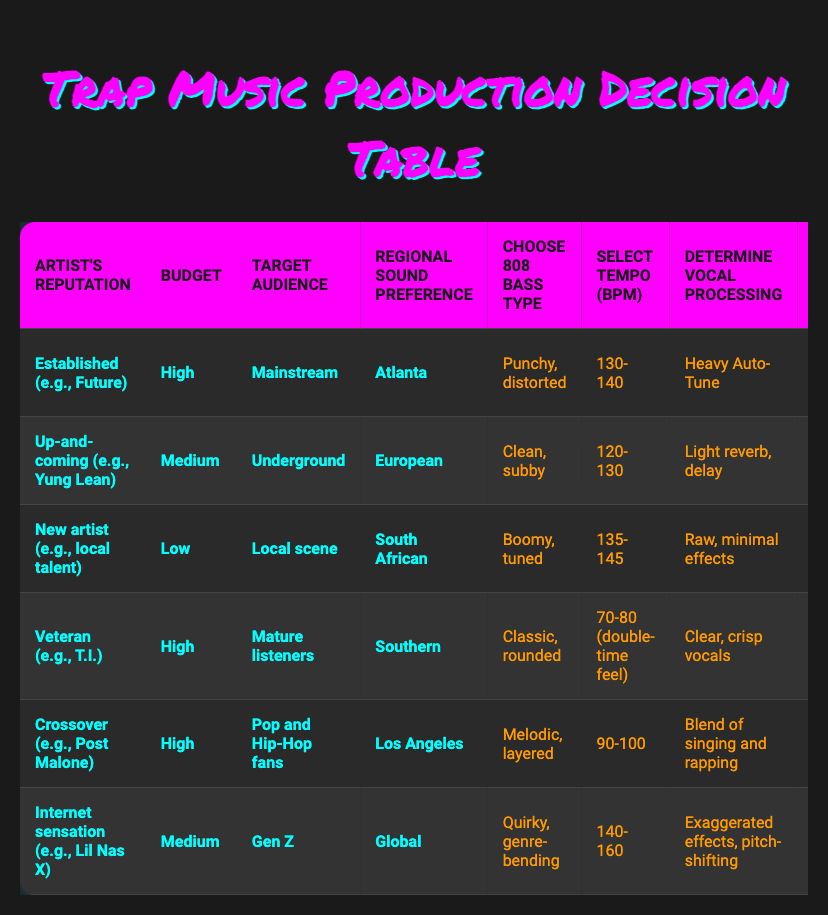What 808 bass type is used by established artists like Future? The table indicates that established artists choose a "Punchy, distorted" 808 bass type.
Answer: Punchy, distorted What is the selected tempo (BPM) for an up-and-coming artist targeting the underground audience? For up-and-coming artists like Yung Lean, the selected tempo (BPM) is "120-130".
Answer: 120-130 Do new artists generally have a low budget for trap music production? According to the table, new artists typically have a "Low" budget, indicating that they generally do not have high financial resources for production.
Answer: Yes Which regional sound preference corresponds with veteran artists like T.I.? The table shows that veteran artists prefer the "Southern" regional sound.
Answer: Southern What are the common elements in the production choices for artists targeting Gen Z? Targeting Gen Z artists like Lil Nas X, they choose a "Quirky, genre-bending" 808 bass, "140-160" BPM, exaggerated effects for vocal processing, and meme-worthy synth sounds.
Answer: Quirky, genre-bending Is there a difference in vocal processing between crossover artists and established artists? The table indicates that crossover artists use a "Blend of singing and rapping" for vocal processing, whereas established artists use "Heavy Auto-Tune", demonstrating a difference in their approaches.
Answer: Yes What is the average BPM selected across the different artist categories? To find the average, we sum the BPM ranges for each category (130-140, 120-130, 135-145, 70-80, 90-100, 140-160). First, finding midpoints gives us (135, 125, 140, 75, 95, 150). Then, adding those: 135 + 125 + 140 + 75 + 95 + 150 = 720. There's a total of 6 data points, so the average BPM is 720/6 = 120 BPM as the rough midpoint.
Answer: 120 BPM Are the synth sounds chosen by crossover artists more radio-friendly compared to those chosen by up-and-coming artists? Yes, crossover artists opt for "Lush, radio-friendly textures", while up-and-coming artists use "Icy, digital leads", suggesting a difference in style catering to audience preferences.
Answer: Yes What type of 808 bass do new artists prefer, and how does it differ from established artists? New artists prefer a "Boomy, tuned" 808 bass, whereas established artists choose a "Punchy, distorted" bass, indicating a shift in sound preference based on artist reputation and experience.
Answer: Boomy, tuned; differs by being more rounded compared to punchy 